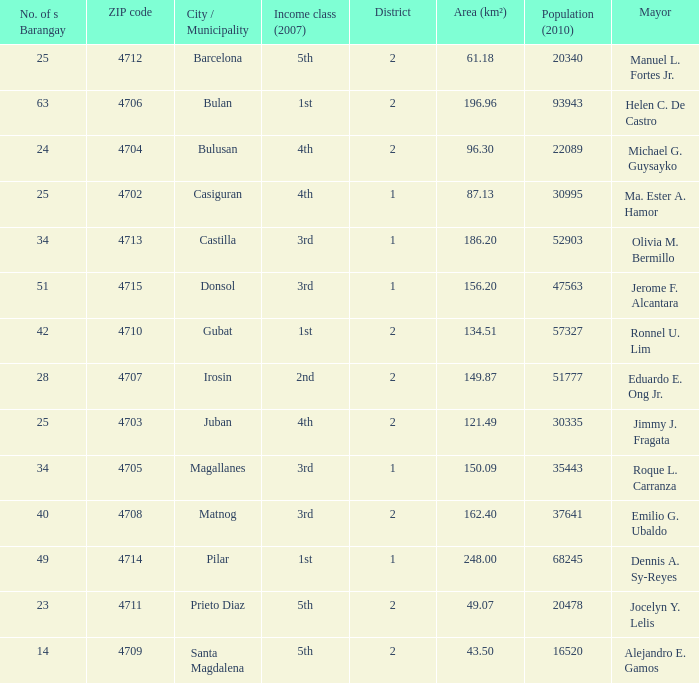What are all the metropolis / municipality where mayor is helen c. De castro Bulan. 